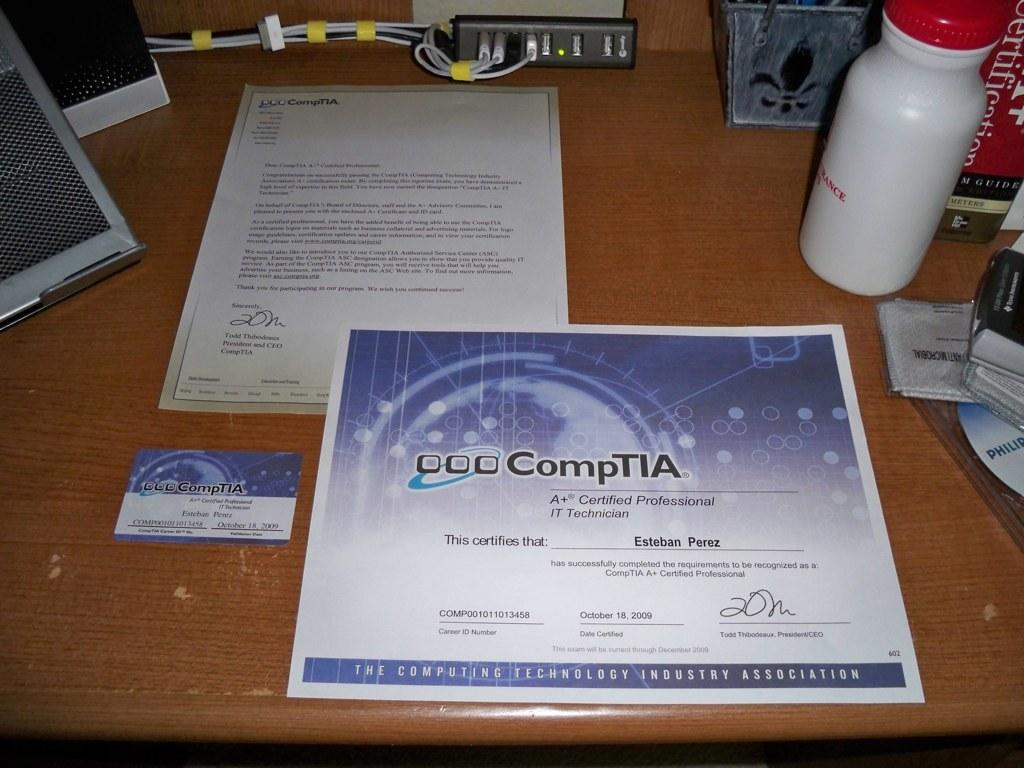<image>
Create a compact narrative representing the image presented. A certificate that says CompTIA is on a table with paperwork and a water bottle. 